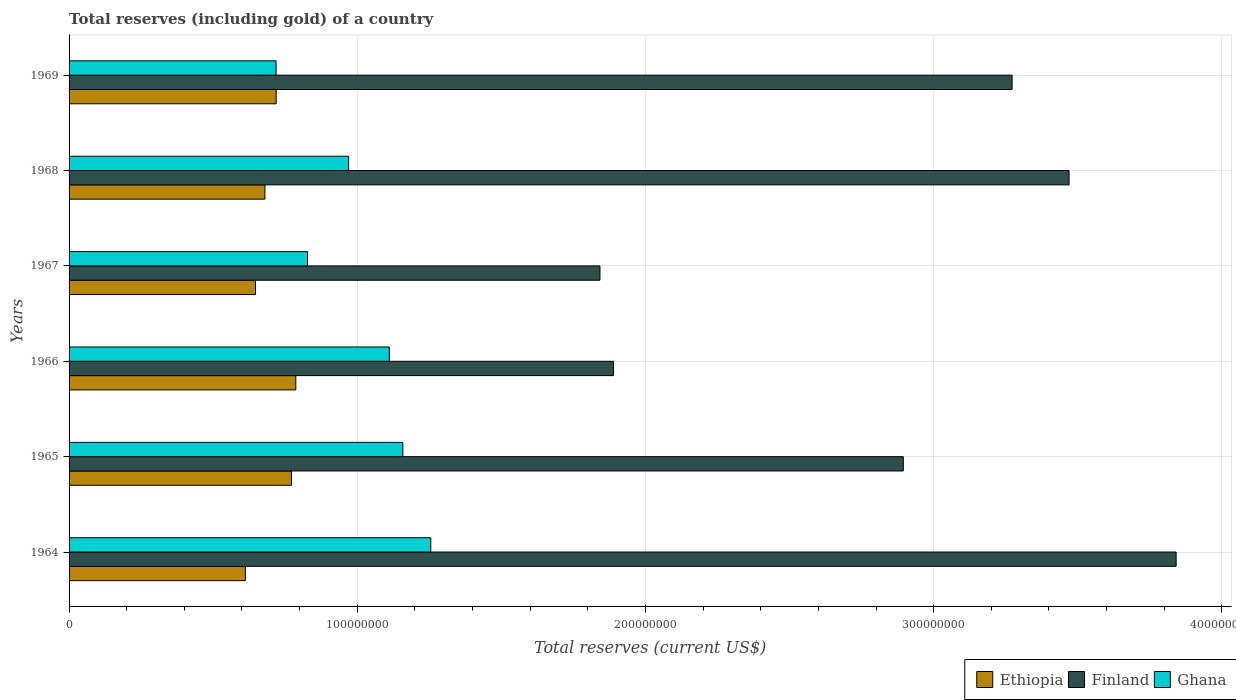How many groups of bars are there?
Offer a terse response. 6. Are the number of bars per tick equal to the number of legend labels?
Offer a very short reply. Yes. Are the number of bars on each tick of the Y-axis equal?
Provide a short and direct response. Yes. What is the label of the 6th group of bars from the top?
Provide a short and direct response. 1964. In how many cases, is the number of bars for a given year not equal to the number of legend labels?
Offer a very short reply. 0. What is the total reserves (including gold) in Ethiopia in 1964?
Your answer should be very brief. 6.12e+07. Across all years, what is the maximum total reserves (including gold) in Ghana?
Ensure brevity in your answer.  1.26e+08. Across all years, what is the minimum total reserves (including gold) in Ghana?
Your answer should be very brief. 7.18e+07. In which year was the total reserves (including gold) in Ethiopia maximum?
Offer a terse response. 1966. In which year was the total reserves (including gold) in Ghana minimum?
Offer a very short reply. 1969. What is the total total reserves (including gold) in Finland in the graph?
Provide a short and direct response. 1.72e+09. What is the difference between the total reserves (including gold) in Ghana in 1967 and that in 1969?
Your response must be concise. 1.09e+07. What is the difference between the total reserves (including gold) in Ethiopia in 1965 and the total reserves (including gold) in Ghana in 1969?
Offer a terse response. 5.33e+06. What is the average total reserves (including gold) in Ghana per year?
Offer a terse response. 1.01e+08. In the year 1964, what is the difference between the total reserves (including gold) in Finland and total reserves (including gold) in Ghana?
Your answer should be very brief. 2.59e+08. What is the ratio of the total reserves (including gold) in Ethiopia in 1964 to that in 1966?
Make the answer very short. 0.78. Is the total reserves (including gold) in Ghana in 1965 less than that in 1966?
Keep it short and to the point. No. Is the difference between the total reserves (including gold) in Finland in 1966 and 1969 greater than the difference between the total reserves (including gold) in Ghana in 1966 and 1969?
Ensure brevity in your answer.  No. What is the difference between the highest and the second highest total reserves (including gold) in Ghana?
Your answer should be compact. 9.71e+06. What is the difference between the highest and the lowest total reserves (including gold) in Finland?
Your answer should be compact. 2.00e+08. In how many years, is the total reserves (including gold) in Ghana greater than the average total reserves (including gold) in Ghana taken over all years?
Make the answer very short. 3. What does the 2nd bar from the top in 1967 represents?
Ensure brevity in your answer.  Finland. What does the 3rd bar from the bottom in 1966 represents?
Offer a very short reply. Ghana. Is it the case that in every year, the sum of the total reserves (including gold) in Ethiopia and total reserves (including gold) in Finland is greater than the total reserves (including gold) in Ghana?
Offer a terse response. Yes. How many bars are there?
Keep it short and to the point. 18. How many years are there in the graph?
Your answer should be compact. 6. What is the difference between two consecutive major ticks on the X-axis?
Offer a very short reply. 1.00e+08. Are the values on the major ticks of X-axis written in scientific E-notation?
Give a very brief answer. No. Does the graph contain grids?
Your response must be concise. Yes. What is the title of the graph?
Provide a short and direct response. Total reserves (including gold) of a country. Does "Maldives" appear as one of the legend labels in the graph?
Keep it short and to the point. No. What is the label or title of the X-axis?
Your response must be concise. Total reserves (current US$). What is the label or title of the Y-axis?
Offer a terse response. Years. What is the Total reserves (current US$) in Ethiopia in 1964?
Provide a short and direct response. 6.12e+07. What is the Total reserves (current US$) in Finland in 1964?
Provide a succinct answer. 3.84e+08. What is the Total reserves (current US$) of Ghana in 1964?
Ensure brevity in your answer.  1.26e+08. What is the Total reserves (current US$) in Ethiopia in 1965?
Ensure brevity in your answer.  7.72e+07. What is the Total reserves (current US$) in Finland in 1965?
Your answer should be compact. 2.89e+08. What is the Total reserves (current US$) in Ghana in 1965?
Offer a terse response. 1.16e+08. What is the Total reserves (current US$) in Ethiopia in 1966?
Your answer should be compact. 7.87e+07. What is the Total reserves (current US$) in Finland in 1966?
Ensure brevity in your answer.  1.89e+08. What is the Total reserves (current US$) of Ghana in 1966?
Offer a very short reply. 1.11e+08. What is the Total reserves (current US$) of Ethiopia in 1967?
Your response must be concise. 6.47e+07. What is the Total reserves (current US$) of Finland in 1967?
Keep it short and to the point. 1.84e+08. What is the Total reserves (current US$) of Ghana in 1967?
Keep it short and to the point. 8.27e+07. What is the Total reserves (current US$) in Ethiopia in 1968?
Your answer should be compact. 6.80e+07. What is the Total reserves (current US$) of Finland in 1968?
Ensure brevity in your answer.  3.47e+08. What is the Total reserves (current US$) of Ghana in 1968?
Your response must be concise. 9.70e+07. What is the Total reserves (current US$) of Ethiopia in 1969?
Offer a terse response. 7.19e+07. What is the Total reserves (current US$) of Finland in 1969?
Ensure brevity in your answer.  3.27e+08. What is the Total reserves (current US$) in Ghana in 1969?
Offer a terse response. 7.18e+07. Across all years, what is the maximum Total reserves (current US$) of Ethiopia?
Keep it short and to the point. 7.87e+07. Across all years, what is the maximum Total reserves (current US$) of Finland?
Your answer should be very brief. 3.84e+08. Across all years, what is the maximum Total reserves (current US$) of Ghana?
Make the answer very short. 1.26e+08. Across all years, what is the minimum Total reserves (current US$) of Ethiopia?
Keep it short and to the point. 6.12e+07. Across all years, what is the minimum Total reserves (current US$) in Finland?
Your response must be concise. 1.84e+08. Across all years, what is the minimum Total reserves (current US$) of Ghana?
Offer a very short reply. 7.18e+07. What is the total Total reserves (current US$) of Ethiopia in the graph?
Ensure brevity in your answer.  4.22e+08. What is the total Total reserves (current US$) in Finland in the graph?
Your answer should be compact. 1.72e+09. What is the total Total reserves (current US$) of Ghana in the graph?
Make the answer very short. 6.04e+08. What is the difference between the Total reserves (current US$) of Ethiopia in 1964 and that in 1965?
Offer a terse response. -1.60e+07. What is the difference between the Total reserves (current US$) of Finland in 1964 and that in 1965?
Make the answer very short. 9.47e+07. What is the difference between the Total reserves (current US$) of Ghana in 1964 and that in 1965?
Your response must be concise. 9.71e+06. What is the difference between the Total reserves (current US$) in Ethiopia in 1964 and that in 1966?
Keep it short and to the point. -1.75e+07. What is the difference between the Total reserves (current US$) in Finland in 1964 and that in 1966?
Give a very brief answer. 1.95e+08. What is the difference between the Total reserves (current US$) in Ghana in 1964 and that in 1966?
Ensure brevity in your answer.  1.44e+07. What is the difference between the Total reserves (current US$) in Ethiopia in 1964 and that in 1967?
Provide a short and direct response. -3.51e+06. What is the difference between the Total reserves (current US$) of Finland in 1964 and that in 1967?
Keep it short and to the point. 2.00e+08. What is the difference between the Total reserves (current US$) in Ghana in 1964 and that in 1967?
Your response must be concise. 4.28e+07. What is the difference between the Total reserves (current US$) in Ethiopia in 1964 and that in 1968?
Keep it short and to the point. -6.78e+06. What is the difference between the Total reserves (current US$) of Finland in 1964 and that in 1968?
Offer a very short reply. 3.71e+07. What is the difference between the Total reserves (current US$) of Ghana in 1964 and that in 1968?
Offer a terse response. 2.85e+07. What is the difference between the Total reserves (current US$) of Ethiopia in 1964 and that in 1969?
Give a very brief answer. -1.07e+07. What is the difference between the Total reserves (current US$) of Finland in 1964 and that in 1969?
Your answer should be very brief. 5.69e+07. What is the difference between the Total reserves (current US$) of Ghana in 1964 and that in 1969?
Offer a terse response. 5.37e+07. What is the difference between the Total reserves (current US$) in Ethiopia in 1965 and that in 1966?
Your answer should be compact. -1.51e+06. What is the difference between the Total reserves (current US$) of Finland in 1965 and that in 1966?
Make the answer very short. 1.01e+08. What is the difference between the Total reserves (current US$) of Ghana in 1965 and that in 1966?
Give a very brief answer. 4.68e+06. What is the difference between the Total reserves (current US$) in Ethiopia in 1965 and that in 1967?
Ensure brevity in your answer.  1.25e+07. What is the difference between the Total reserves (current US$) of Finland in 1965 and that in 1967?
Offer a very short reply. 1.05e+08. What is the difference between the Total reserves (current US$) in Ghana in 1965 and that in 1967?
Offer a very short reply. 3.31e+07. What is the difference between the Total reserves (current US$) of Ethiopia in 1965 and that in 1968?
Your answer should be very brief. 9.21e+06. What is the difference between the Total reserves (current US$) of Finland in 1965 and that in 1968?
Keep it short and to the point. -5.75e+07. What is the difference between the Total reserves (current US$) in Ghana in 1965 and that in 1968?
Provide a succinct answer. 1.88e+07. What is the difference between the Total reserves (current US$) in Ethiopia in 1965 and that in 1969?
Provide a short and direct response. 5.31e+06. What is the difference between the Total reserves (current US$) in Finland in 1965 and that in 1969?
Ensure brevity in your answer.  -3.77e+07. What is the difference between the Total reserves (current US$) in Ghana in 1965 and that in 1969?
Your response must be concise. 4.40e+07. What is the difference between the Total reserves (current US$) of Ethiopia in 1966 and that in 1967?
Make the answer very short. 1.40e+07. What is the difference between the Total reserves (current US$) of Finland in 1966 and that in 1967?
Offer a terse response. 4.70e+06. What is the difference between the Total reserves (current US$) of Ghana in 1966 and that in 1967?
Offer a terse response. 2.84e+07. What is the difference between the Total reserves (current US$) of Ethiopia in 1966 and that in 1968?
Keep it short and to the point. 1.07e+07. What is the difference between the Total reserves (current US$) in Finland in 1966 and that in 1968?
Offer a terse response. -1.58e+08. What is the difference between the Total reserves (current US$) in Ghana in 1966 and that in 1968?
Provide a short and direct response. 1.41e+07. What is the difference between the Total reserves (current US$) in Ethiopia in 1966 and that in 1969?
Offer a very short reply. 6.82e+06. What is the difference between the Total reserves (current US$) of Finland in 1966 and that in 1969?
Keep it short and to the point. -1.38e+08. What is the difference between the Total reserves (current US$) of Ghana in 1966 and that in 1969?
Offer a terse response. 3.93e+07. What is the difference between the Total reserves (current US$) in Ethiopia in 1967 and that in 1968?
Keep it short and to the point. -3.28e+06. What is the difference between the Total reserves (current US$) in Finland in 1967 and that in 1968?
Your response must be concise. -1.63e+08. What is the difference between the Total reserves (current US$) of Ghana in 1967 and that in 1968?
Provide a short and direct response. -1.43e+07. What is the difference between the Total reserves (current US$) of Ethiopia in 1967 and that in 1969?
Your answer should be very brief. -7.18e+06. What is the difference between the Total reserves (current US$) of Finland in 1967 and that in 1969?
Your answer should be very brief. -1.43e+08. What is the difference between the Total reserves (current US$) in Ghana in 1967 and that in 1969?
Ensure brevity in your answer.  1.09e+07. What is the difference between the Total reserves (current US$) in Ethiopia in 1968 and that in 1969?
Your answer should be very brief. -3.90e+06. What is the difference between the Total reserves (current US$) of Finland in 1968 and that in 1969?
Give a very brief answer. 1.98e+07. What is the difference between the Total reserves (current US$) of Ghana in 1968 and that in 1969?
Keep it short and to the point. 2.52e+07. What is the difference between the Total reserves (current US$) in Ethiopia in 1964 and the Total reserves (current US$) in Finland in 1965?
Provide a succinct answer. -2.28e+08. What is the difference between the Total reserves (current US$) of Ethiopia in 1964 and the Total reserves (current US$) of Ghana in 1965?
Offer a terse response. -5.46e+07. What is the difference between the Total reserves (current US$) in Finland in 1964 and the Total reserves (current US$) in Ghana in 1965?
Ensure brevity in your answer.  2.68e+08. What is the difference between the Total reserves (current US$) of Ethiopia in 1964 and the Total reserves (current US$) of Finland in 1966?
Give a very brief answer. -1.28e+08. What is the difference between the Total reserves (current US$) of Ethiopia in 1964 and the Total reserves (current US$) of Ghana in 1966?
Ensure brevity in your answer.  -5.00e+07. What is the difference between the Total reserves (current US$) of Finland in 1964 and the Total reserves (current US$) of Ghana in 1966?
Give a very brief answer. 2.73e+08. What is the difference between the Total reserves (current US$) in Ethiopia in 1964 and the Total reserves (current US$) in Finland in 1967?
Offer a very short reply. -1.23e+08. What is the difference between the Total reserves (current US$) of Ethiopia in 1964 and the Total reserves (current US$) of Ghana in 1967?
Offer a very short reply. -2.16e+07. What is the difference between the Total reserves (current US$) of Finland in 1964 and the Total reserves (current US$) of Ghana in 1967?
Your response must be concise. 3.01e+08. What is the difference between the Total reserves (current US$) of Ethiopia in 1964 and the Total reserves (current US$) of Finland in 1968?
Provide a short and direct response. -2.86e+08. What is the difference between the Total reserves (current US$) in Ethiopia in 1964 and the Total reserves (current US$) in Ghana in 1968?
Provide a short and direct response. -3.58e+07. What is the difference between the Total reserves (current US$) of Finland in 1964 and the Total reserves (current US$) of Ghana in 1968?
Provide a succinct answer. 2.87e+08. What is the difference between the Total reserves (current US$) of Ethiopia in 1964 and the Total reserves (current US$) of Finland in 1969?
Give a very brief answer. -2.66e+08. What is the difference between the Total reserves (current US$) of Ethiopia in 1964 and the Total reserves (current US$) of Ghana in 1969?
Your response must be concise. -1.07e+07. What is the difference between the Total reserves (current US$) of Finland in 1964 and the Total reserves (current US$) of Ghana in 1969?
Your response must be concise. 3.12e+08. What is the difference between the Total reserves (current US$) of Ethiopia in 1965 and the Total reserves (current US$) of Finland in 1966?
Offer a very short reply. -1.12e+08. What is the difference between the Total reserves (current US$) of Ethiopia in 1965 and the Total reserves (current US$) of Ghana in 1966?
Provide a succinct answer. -3.40e+07. What is the difference between the Total reserves (current US$) in Finland in 1965 and the Total reserves (current US$) in Ghana in 1966?
Ensure brevity in your answer.  1.78e+08. What is the difference between the Total reserves (current US$) of Ethiopia in 1965 and the Total reserves (current US$) of Finland in 1967?
Ensure brevity in your answer.  -1.07e+08. What is the difference between the Total reserves (current US$) of Ethiopia in 1965 and the Total reserves (current US$) of Ghana in 1967?
Your response must be concise. -5.57e+06. What is the difference between the Total reserves (current US$) of Finland in 1965 and the Total reserves (current US$) of Ghana in 1967?
Ensure brevity in your answer.  2.07e+08. What is the difference between the Total reserves (current US$) of Ethiopia in 1965 and the Total reserves (current US$) of Finland in 1968?
Make the answer very short. -2.70e+08. What is the difference between the Total reserves (current US$) of Ethiopia in 1965 and the Total reserves (current US$) of Ghana in 1968?
Keep it short and to the point. -1.98e+07. What is the difference between the Total reserves (current US$) of Finland in 1965 and the Total reserves (current US$) of Ghana in 1968?
Provide a short and direct response. 1.92e+08. What is the difference between the Total reserves (current US$) in Ethiopia in 1965 and the Total reserves (current US$) in Finland in 1969?
Your answer should be compact. -2.50e+08. What is the difference between the Total reserves (current US$) in Ethiopia in 1965 and the Total reserves (current US$) in Ghana in 1969?
Ensure brevity in your answer.  5.33e+06. What is the difference between the Total reserves (current US$) of Finland in 1965 and the Total reserves (current US$) of Ghana in 1969?
Give a very brief answer. 2.18e+08. What is the difference between the Total reserves (current US$) of Ethiopia in 1966 and the Total reserves (current US$) of Finland in 1967?
Your response must be concise. -1.06e+08. What is the difference between the Total reserves (current US$) in Ethiopia in 1966 and the Total reserves (current US$) in Ghana in 1967?
Your answer should be very brief. -4.06e+06. What is the difference between the Total reserves (current US$) of Finland in 1966 and the Total reserves (current US$) of Ghana in 1967?
Offer a very short reply. 1.06e+08. What is the difference between the Total reserves (current US$) of Ethiopia in 1966 and the Total reserves (current US$) of Finland in 1968?
Give a very brief answer. -2.68e+08. What is the difference between the Total reserves (current US$) of Ethiopia in 1966 and the Total reserves (current US$) of Ghana in 1968?
Make the answer very short. -1.83e+07. What is the difference between the Total reserves (current US$) of Finland in 1966 and the Total reserves (current US$) of Ghana in 1968?
Provide a short and direct response. 9.19e+07. What is the difference between the Total reserves (current US$) in Ethiopia in 1966 and the Total reserves (current US$) in Finland in 1969?
Give a very brief answer. -2.49e+08. What is the difference between the Total reserves (current US$) in Ethiopia in 1966 and the Total reserves (current US$) in Ghana in 1969?
Ensure brevity in your answer.  6.84e+06. What is the difference between the Total reserves (current US$) in Finland in 1966 and the Total reserves (current US$) in Ghana in 1969?
Make the answer very short. 1.17e+08. What is the difference between the Total reserves (current US$) of Ethiopia in 1967 and the Total reserves (current US$) of Finland in 1968?
Your answer should be very brief. -2.82e+08. What is the difference between the Total reserves (current US$) of Ethiopia in 1967 and the Total reserves (current US$) of Ghana in 1968?
Provide a succinct answer. -3.23e+07. What is the difference between the Total reserves (current US$) of Finland in 1967 and the Total reserves (current US$) of Ghana in 1968?
Offer a terse response. 8.72e+07. What is the difference between the Total reserves (current US$) in Ethiopia in 1967 and the Total reserves (current US$) in Finland in 1969?
Your answer should be compact. -2.63e+08. What is the difference between the Total reserves (current US$) of Ethiopia in 1967 and the Total reserves (current US$) of Ghana in 1969?
Give a very brief answer. -7.15e+06. What is the difference between the Total reserves (current US$) in Finland in 1967 and the Total reserves (current US$) in Ghana in 1969?
Provide a short and direct response. 1.12e+08. What is the difference between the Total reserves (current US$) of Ethiopia in 1968 and the Total reserves (current US$) of Finland in 1969?
Give a very brief answer. -2.59e+08. What is the difference between the Total reserves (current US$) of Ethiopia in 1968 and the Total reserves (current US$) of Ghana in 1969?
Keep it short and to the point. -3.87e+06. What is the difference between the Total reserves (current US$) of Finland in 1968 and the Total reserves (current US$) of Ghana in 1969?
Ensure brevity in your answer.  2.75e+08. What is the average Total reserves (current US$) in Ethiopia per year?
Offer a very short reply. 7.03e+07. What is the average Total reserves (current US$) in Finland per year?
Offer a terse response. 2.87e+08. What is the average Total reserves (current US$) in Ghana per year?
Provide a succinct answer. 1.01e+08. In the year 1964, what is the difference between the Total reserves (current US$) of Ethiopia and Total reserves (current US$) of Finland?
Provide a short and direct response. -3.23e+08. In the year 1964, what is the difference between the Total reserves (current US$) in Ethiopia and Total reserves (current US$) in Ghana?
Your response must be concise. -6.43e+07. In the year 1964, what is the difference between the Total reserves (current US$) of Finland and Total reserves (current US$) of Ghana?
Offer a very short reply. 2.59e+08. In the year 1965, what is the difference between the Total reserves (current US$) of Ethiopia and Total reserves (current US$) of Finland?
Your answer should be compact. -2.12e+08. In the year 1965, what is the difference between the Total reserves (current US$) of Ethiopia and Total reserves (current US$) of Ghana?
Give a very brief answer. -3.86e+07. In the year 1965, what is the difference between the Total reserves (current US$) in Finland and Total reserves (current US$) in Ghana?
Keep it short and to the point. 1.74e+08. In the year 1966, what is the difference between the Total reserves (current US$) in Ethiopia and Total reserves (current US$) in Finland?
Your answer should be compact. -1.10e+08. In the year 1966, what is the difference between the Total reserves (current US$) of Ethiopia and Total reserves (current US$) of Ghana?
Ensure brevity in your answer.  -3.25e+07. In the year 1966, what is the difference between the Total reserves (current US$) of Finland and Total reserves (current US$) of Ghana?
Keep it short and to the point. 7.78e+07. In the year 1967, what is the difference between the Total reserves (current US$) of Ethiopia and Total reserves (current US$) of Finland?
Make the answer very short. -1.20e+08. In the year 1967, what is the difference between the Total reserves (current US$) in Ethiopia and Total reserves (current US$) in Ghana?
Your answer should be very brief. -1.81e+07. In the year 1967, what is the difference between the Total reserves (current US$) of Finland and Total reserves (current US$) of Ghana?
Make the answer very short. 1.01e+08. In the year 1968, what is the difference between the Total reserves (current US$) of Ethiopia and Total reserves (current US$) of Finland?
Ensure brevity in your answer.  -2.79e+08. In the year 1968, what is the difference between the Total reserves (current US$) in Ethiopia and Total reserves (current US$) in Ghana?
Your answer should be very brief. -2.90e+07. In the year 1968, what is the difference between the Total reserves (current US$) of Finland and Total reserves (current US$) of Ghana?
Provide a short and direct response. 2.50e+08. In the year 1969, what is the difference between the Total reserves (current US$) in Ethiopia and Total reserves (current US$) in Finland?
Provide a succinct answer. -2.55e+08. In the year 1969, what is the difference between the Total reserves (current US$) in Ethiopia and Total reserves (current US$) in Ghana?
Offer a terse response. 2.68e+04. In the year 1969, what is the difference between the Total reserves (current US$) in Finland and Total reserves (current US$) in Ghana?
Your answer should be compact. 2.55e+08. What is the ratio of the Total reserves (current US$) of Ethiopia in 1964 to that in 1965?
Offer a terse response. 0.79. What is the ratio of the Total reserves (current US$) in Finland in 1964 to that in 1965?
Your response must be concise. 1.33. What is the ratio of the Total reserves (current US$) in Ghana in 1964 to that in 1965?
Make the answer very short. 1.08. What is the ratio of the Total reserves (current US$) of Ethiopia in 1964 to that in 1966?
Offer a terse response. 0.78. What is the ratio of the Total reserves (current US$) of Finland in 1964 to that in 1966?
Your answer should be compact. 2.03. What is the ratio of the Total reserves (current US$) of Ghana in 1964 to that in 1966?
Provide a short and direct response. 1.13. What is the ratio of the Total reserves (current US$) of Ethiopia in 1964 to that in 1967?
Your answer should be compact. 0.95. What is the ratio of the Total reserves (current US$) in Finland in 1964 to that in 1967?
Offer a terse response. 2.09. What is the ratio of the Total reserves (current US$) of Ghana in 1964 to that in 1967?
Provide a succinct answer. 1.52. What is the ratio of the Total reserves (current US$) of Ethiopia in 1964 to that in 1968?
Provide a short and direct response. 0.9. What is the ratio of the Total reserves (current US$) of Finland in 1964 to that in 1968?
Offer a very short reply. 1.11. What is the ratio of the Total reserves (current US$) of Ghana in 1964 to that in 1968?
Ensure brevity in your answer.  1.29. What is the ratio of the Total reserves (current US$) in Ethiopia in 1964 to that in 1969?
Your answer should be very brief. 0.85. What is the ratio of the Total reserves (current US$) of Finland in 1964 to that in 1969?
Your answer should be very brief. 1.17. What is the ratio of the Total reserves (current US$) in Ghana in 1964 to that in 1969?
Your answer should be very brief. 1.75. What is the ratio of the Total reserves (current US$) in Ethiopia in 1965 to that in 1966?
Provide a succinct answer. 0.98. What is the ratio of the Total reserves (current US$) of Finland in 1965 to that in 1966?
Keep it short and to the point. 1.53. What is the ratio of the Total reserves (current US$) in Ghana in 1965 to that in 1966?
Offer a terse response. 1.04. What is the ratio of the Total reserves (current US$) of Ethiopia in 1965 to that in 1967?
Provide a short and direct response. 1.19. What is the ratio of the Total reserves (current US$) in Finland in 1965 to that in 1967?
Ensure brevity in your answer.  1.57. What is the ratio of the Total reserves (current US$) in Ghana in 1965 to that in 1967?
Provide a short and direct response. 1.4. What is the ratio of the Total reserves (current US$) in Ethiopia in 1965 to that in 1968?
Keep it short and to the point. 1.14. What is the ratio of the Total reserves (current US$) in Finland in 1965 to that in 1968?
Your response must be concise. 0.83. What is the ratio of the Total reserves (current US$) in Ghana in 1965 to that in 1968?
Your answer should be very brief. 1.19. What is the ratio of the Total reserves (current US$) of Ethiopia in 1965 to that in 1969?
Keep it short and to the point. 1.07. What is the ratio of the Total reserves (current US$) in Finland in 1965 to that in 1969?
Give a very brief answer. 0.88. What is the ratio of the Total reserves (current US$) in Ghana in 1965 to that in 1969?
Provide a succinct answer. 1.61. What is the ratio of the Total reserves (current US$) of Ethiopia in 1966 to that in 1967?
Provide a succinct answer. 1.22. What is the ratio of the Total reserves (current US$) of Finland in 1966 to that in 1967?
Provide a succinct answer. 1.03. What is the ratio of the Total reserves (current US$) in Ghana in 1966 to that in 1967?
Provide a short and direct response. 1.34. What is the ratio of the Total reserves (current US$) in Ethiopia in 1966 to that in 1968?
Your answer should be compact. 1.16. What is the ratio of the Total reserves (current US$) of Finland in 1966 to that in 1968?
Offer a terse response. 0.54. What is the ratio of the Total reserves (current US$) in Ghana in 1966 to that in 1968?
Make the answer very short. 1.15. What is the ratio of the Total reserves (current US$) of Ethiopia in 1966 to that in 1969?
Provide a short and direct response. 1.09. What is the ratio of the Total reserves (current US$) in Finland in 1966 to that in 1969?
Keep it short and to the point. 0.58. What is the ratio of the Total reserves (current US$) of Ghana in 1966 to that in 1969?
Make the answer very short. 1.55. What is the ratio of the Total reserves (current US$) of Ethiopia in 1967 to that in 1968?
Your answer should be very brief. 0.95. What is the ratio of the Total reserves (current US$) in Finland in 1967 to that in 1968?
Your answer should be compact. 0.53. What is the ratio of the Total reserves (current US$) in Ghana in 1967 to that in 1968?
Give a very brief answer. 0.85. What is the ratio of the Total reserves (current US$) in Ethiopia in 1967 to that in 1969?
Offer a terse response. 0.9. What is the ratio of the Total reserves (current US$) of Finland in 1967 to that in 1969?
Your answer should be compact. 0.56. What is the ratio of the Total reserves (current US$) in Ghana in 1967 to that in 1969?
Keep it short and to the point. 1.15. What is the ratio of the Total reserves (current US$) of Ethiopia in 1968 to that in 1969?
Keep it short and to the point. 0.95. What is the ratio of the Total reserves (current US$) of Finland in 1968 to that in 1969?
Your answer should be very brief. 1.06. What is the ratio of the Total reserves (current US$) in Ghana in 1968 to that in 1969?
Keep it short and to the point. 1.35. What is the difference between the highest and the second highest Total reserves (current US$) of Ethiopia?
Ensure brevity in your answer.  1.51e+06. What is the difference between the highest and the second highest Total reserves (current US$) in Finland?
Offer a very short reply. 3.71e+07. What is the difference between the highest and the second highest Total reserves (current US$) in Ghana?
Give a very brief answer. 9.71e+06. What is the difference between the highest and the lowest Total reserves (current US$) of Ethiopia?
Provide a short and direct response. 1.75e+07. What is the difference between the highest and the lowest Total reserves (current US$) in Finland?
Provide a succinct answer. 2.00e+08. What is the difference between the highest and the lowest Total reserves (current US$) in Ghana?
Your answer should be very brief. 5.37e+07. 